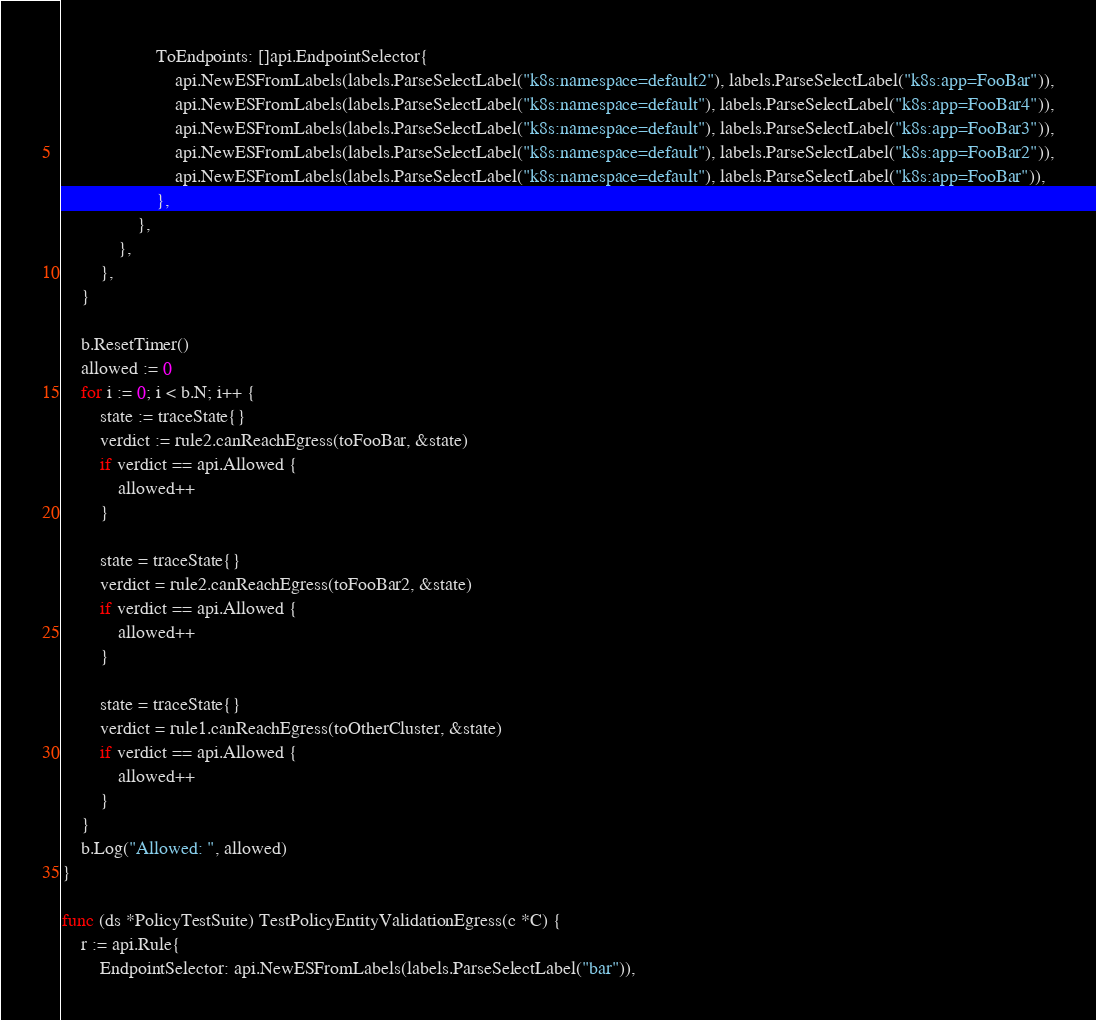<code> <loc_0><loc_0><loc_500><loc_500><_Go_>					ToEndpoints: []api.EndpointSelector{
						api.NewESFromLabels(labels.ParseSelectLabel("k8s:namespace=default2"), labels.ParseSelectLabel("k8s:app=FooBar")),
						api.NewESFromLabels(labels.ParseSelectLabel("k8s:namespace=default"), labels.ParseSelectLabel("k8s:app=FooBar4")),
						api.NewESFromLabels(labels.ParseSelectLabel("k8s:namespace=default"), labels.ParseSelectLabel("k8s:app=FooBar3")),
						api.NewESFromLabels(labels.ParseSelectLabel("k8s:namespace=default"), labels.ParseSelectLabel("k8s:app=FooBar2")),
						api.NewESFromLabels(labels.ParseSelectLabel("k8s:namespace=default"), labels.ParseSelectLabel("k8s:app=FooBar")),
					},
				},
			},
		},
	}

	b.ResetTimer()
	allowed := 0
	for i := 0; i < b.N; i++ {
		state := traceState{}
		verdict := rule2.canReachEgress(toFooBar, &state)
		if verdict == api.Allowed {
			allowed++
		}

		state = traceState{}
		verdict = rule2.canReachEgress(toFooBar2, &state)
		if verdict == api.Allowed {
			allowed++
		}

		state = traceState{}
		verdict = rule1.canReachEgress(toOtherCluster, &state)
		if verdict == api.Allowed {
			allowed++
		}
	}
	b.Log("Allowed: ", allowed)
}

func (ds *PolicyTestSuite) TestPolicyEntityValidationEgress(c *C) {
	r := api.Rule{
		EndpointSelector: api.NewESFromLabels(labels.ParseSelectLabel("bar")),</code> 